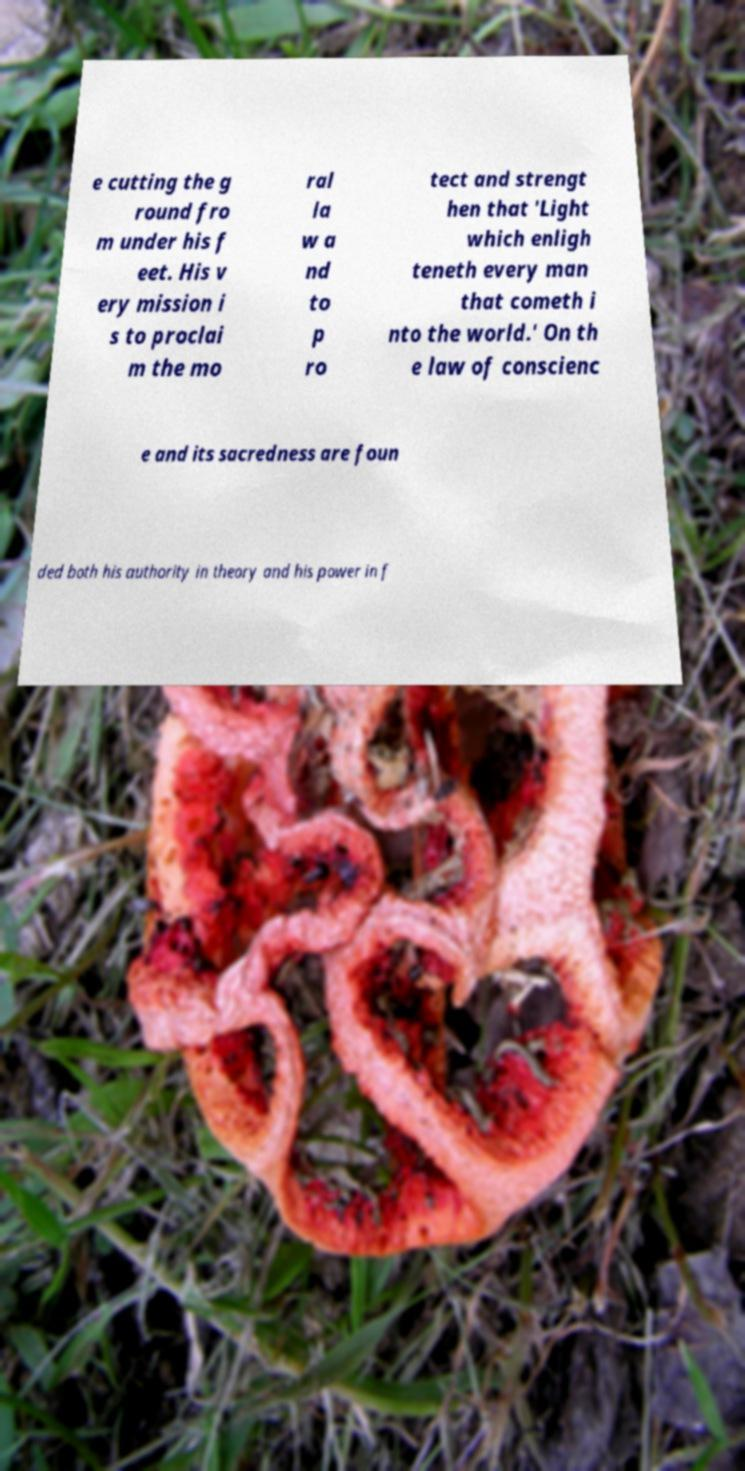Please read and relay the text visible in this image. What does it say? e cutting the g round fro m under his f eet. His v ery mission i s to proclai m the mo ral la w a nd to p ro tect and strengt hen that 'Light which enligh teneth every man that cometh i nto the world.' On th e law of conscienc e and its sacredness are foun ded both his authority in theory and his power in f 